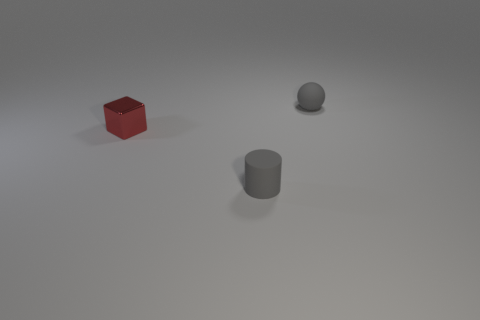Add 1 large blue shiny cylinders. How many objects exist? 4 Subtract all cylinders. How many objects are left? 2 Add 3 red blocks. How many red blocks are left? 4 Add 1 tiny gray spheres. How many tiny gray spheres exist? 2 Subtract 0 red balls. How many objects are left? 3 Subtract all yellow shiny things. Subtract all matte balls. How many objects are left? 2 